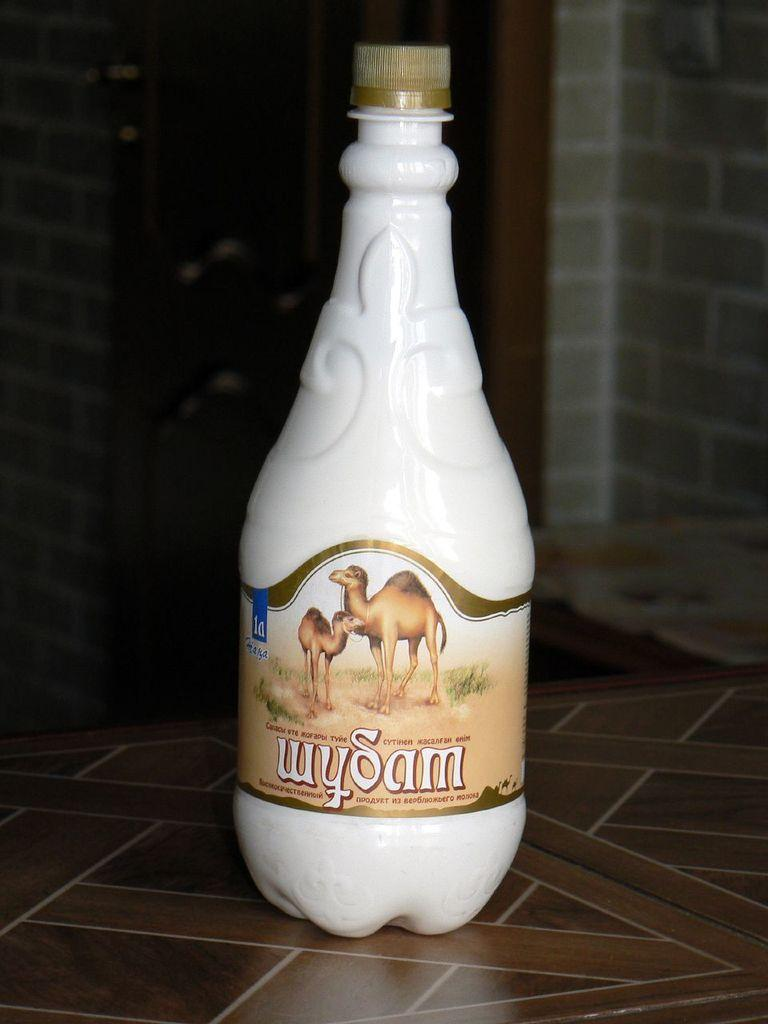<image>
Share a concise interpretation of the image provided. A white bottle of Wysam features a label that depicts two camels. 